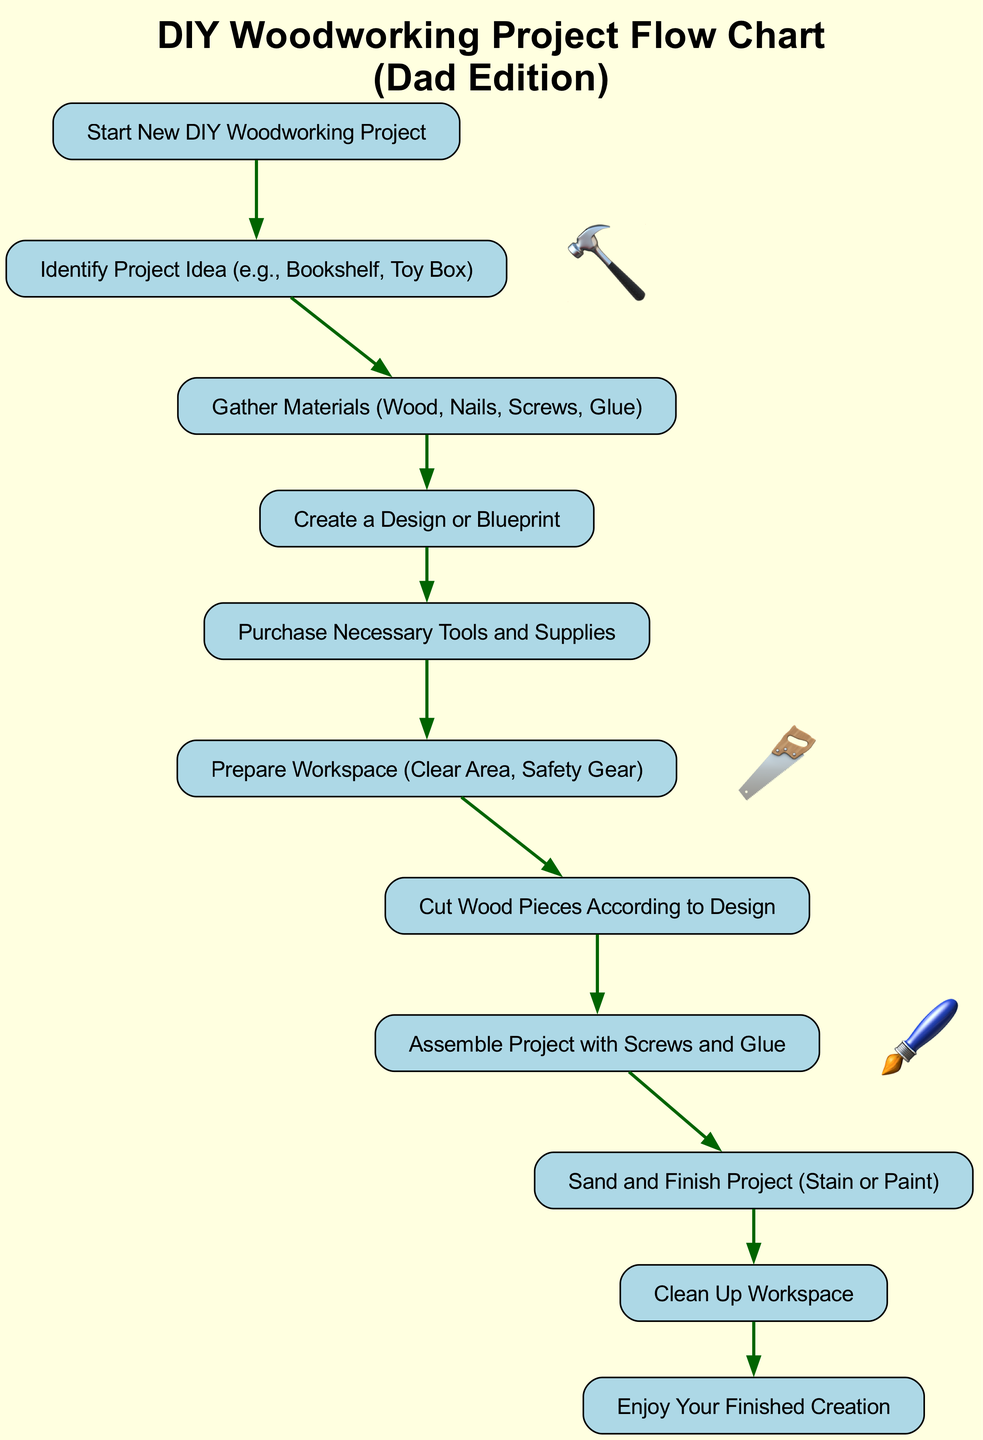What is the first step in the flow chart? The first step is labeled "Start New DIY Woodworking Project," which indicates the initiation of the process.
Answer: Start New DIY Woodworking Project How many materials are mentioned to gather in the flow chart? The flow chart lists "Wood, Nails, Screws, Glue" as the materials to gather, totaling four items.
Answer: Four What action follows after creating a design? After creating a design, the next action is "Purchase Necessary Tools and Supplies," which shows the progression in the project workflow.
Answer: Purchase Necessary Tools and Supplies What is the last step depicted in the flow chart? The last step in the flow chart is "Enjoy Your Finished Creation," highlighting the completion of the project process.
Answer: Enjoy Your Finished Creation Which step involves using screws and glue? The step that involves using screws and glue is "Assemble Project with Screws and Glue," which indicates how the components will be put together.
Answer: Assemble Project with Screws and Glue What node directly precedes "Cut Wood"? The node directly preceding "Cut Wood" in the flow chart is "Prepare Workspace," which suggests that workspace preparation is needed before cutting wood pieces.
Answer: Prepare Workspace How many decorations are included in the flow chart? The flow chart includes three decorations: a hammer, saw, and paint, distinguishing the DIY theme.
Answer: Three What is required before "Finish Project"? Before "Finish Project," the step outlined is "Sand and Finish Project (Stain or Paint)," showing that finishing touches are necessary.
Answer: Sand and Finish Project (Stain or Paint) 